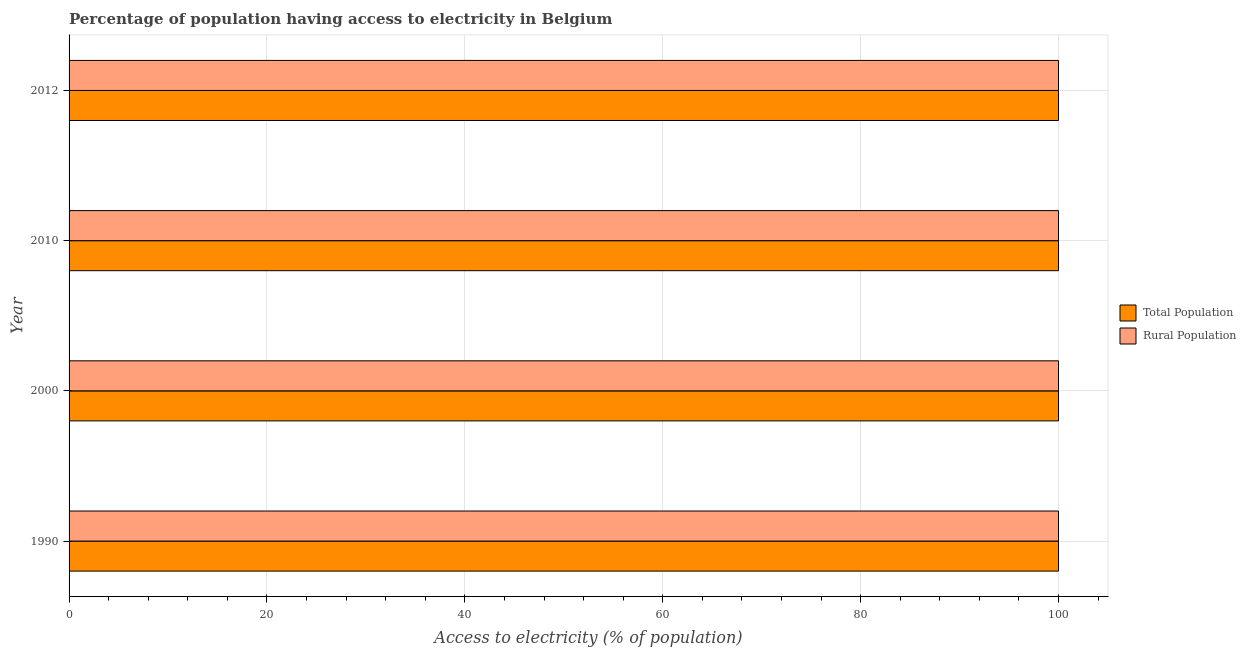How many different coloured bars are there?
Keep it short and to the point. 2. How many groups of bars are there?
Make the answer very short. 4. Are the number of bars per tick equal to the number of legend labels?
Provide a succinct answer. Yes. What is the label of the 2nd group of bars from the top?
Your response must be concise. 2010. In how many cases, is the number of bars for a given year not equal to the number of legend labels?
Make the answer very short. 0. What is the percentage of rural population having access to electricity in 2012?
Keep it short and to the point. 100. Across all years, what is the maximum percentage of population having access to electricity?
Give a very brief answer. 100. Across all years, what is the minimum percentage of population having access to electricity?
Make the answer very short. 100. In which year was the percentage of population having access to electricity maximum?
Your response must be concise. 1990. What is the total percentage of rural population having access to electricity in the graph?
Keep it short and to the point. 400. What is the difference between the percentage of rural population having access to electricity in 1990 and that in 2012?
Offer a terse response. 0. In how many years, is the percentage of rural population having access to electricity greater than 4 %?
Your response must be concise. 4. What is the ratio of the percentage of rural population having access to electricity in 2010 to that in 2012?
Provide a short and direct response. 1. Is the percentage of population having access to electricity in 2000 less than that in 2012?
Offer a very short reply. No. What is the difference between the highest and the second highest percentage of rural population having access to electricity?
Make the answer very short. 0. In how many years, is the percentage of population having access to electricity greater than the average percentage of population having access to electricity taken over all years?
Your response must be concise. 0. Is the sum of the percentage of population having access to electricity in 1990 and 2000 greater than the maximum percentage of rural population having access to electricity across all years?
Your answer should be compact. Yes. What does the 2nd bar from the top in 2010 represents?
Offer a very short reply. Total Population. What does the 1st bar from the bottom in 2012 represents?
Offer a terse response. Total Population. Are all the bars in the graph horizontal?
Offer a terse response. Yes. How many years are there in the graph?
Keep it short and to the point. 4. Are the values on the major ticks of X-axis written in scientific E-notation?
Your answer should be very brief. No. Does the graph contain any zero values?
Ensure brevity in your answer.  No. How many legend labels are there?
Give a very brief answer. 2. How are the legend labels stacked?
Offer a terse response. Vertical. What is the title of the graph?
Give a very brief answer. Percentage of population having access to electricity in Belgium. What is the label or title of the X-axis?
Provide a short and direct response. Access to electricity (% of population). What is the label or title of the Y-axis?
Make the answer very short. Year. What is the Access to electricity (% of population) of Rural Population in 1990?
Your answer should be compact. 100. What is the Access to electricity (% of population) of Rural Population in 2000?
Your answer should be very brief. 100. What is the Access to electricity (% of population) of Total Population in 2010?
Ensure brevity in your answer.  100. What is the Access to electricity (% of population) of Total Population in 2012?
Offer a very short reply. 100. Across all years, what is the maximum Access to electricity (% of population) in Rural Population?
Your answer should be compact. 100. Across all years, what is the minimum Access to electricity (% of population) in Total Population?
Make the answer very short. 100. What is the total Access to electricity (% of population) in Rural Population in the graph?
Keep it short and to the point. 400. What is the difference between the Access to electricity (% of population) in Total Population in 1990 and that in 2000?
Your response must be concise. 0. What is the difference between the Access to electricity (% of population) in Rural Population in 1990 and that in 2000?
Give a very brief answer. 0. What is the difference between the Access to electricity (% of population) of Total Population in 1990 and that in 2010?
Your response must be concise. 0. What is the difference between the Access to electricity (% of population) in Rural Population in 1990 and that in 2010?
Ensure brevity in your answer.  0. What is the difference between the Access to electricity (% of population) in Total Population in 1990 and that in 2012?
Your answer should be compact. 0. What is the difference between the Access to electricity (% of population) in Total Population in 2000 and that in 2010?
Offer a terse response. 0. What is the difference between the Access to electricity (% of population) in Total Population in 2010 and that in 2012?
Keep it short and to the point. 0. What is the difference between the Access to electricity (% of population) of Total Population in 2010 and the Access to electricity (% of population) of Rural Population in 2012?
Offer a very short reply. 0. In the year 1990, what is the difference between the Access to electricity (% of population) in Total Population and Access to electricity (% of population) in Rural Population?
Make the answer very short. 0. In the year 2000, what is the difference between the Access to electricity (% of population) in Total Population and Access to electricity (% of population) in Rural Population?
Offer a terse response. 0. In the year 2010, what is the difference between the Access to electricity (% of population) of Total Population and Access to electricity (% of population) of Rural Population?
Provide a short and direct response. 0. In the year 2012, what is the difference between the Access to electricity (% of population) in Total Population and Access to electricity (% of population) in Rural Population?
Provide a short and direct response. 0. What is the ratio of the Access to electricity (% of population) of Total Population in 1990 to that in 2000?
Ensure brevity in your answer.  1. What is the ratio of the Access to electricity (% of population) of Total Population in 1990 to that in 2010?
Give a very brief answer. 1. What is the ratio of the Access to electricity (% of population) of Rural Population in 1990 to that in 2010?
Provide a succinct answer. 1. What is the ratio of the Access to electricity (% of population) of Total Population in 1990 to that in 2012?
Keep it short and to the point. 1. What is the ratio of the Access to electricity (% of population) of Total Population in 2000 to that in 2010?
Keep it short and to the point. 1. What is the ratio of the Access to electricity (% of population) of Rural Population in 2010 to that in 2012?
Provide a succinct answer. 1. What is the difference between the highest and the second highest Access to electricity (% of population) of Total Population?
Provide a succinct answer. 0. What is the difference between the highest and the second highest Access to electricity (% of population) of Rural Population?
Make the answer very short. 0. What is the difference between the highest and the lowest Access to electricity (% of population) in Total Population?
Your answer should be compact. 0. 